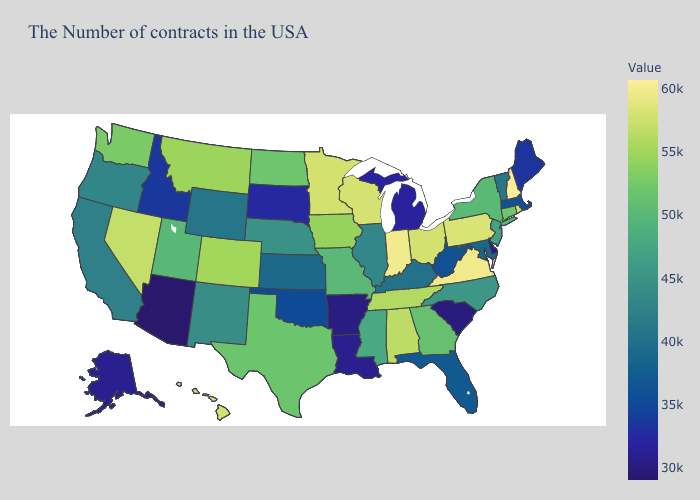Does the map have missing data?
Short answer required. No. Is the legend a continuous bar?
Be succinct. Yes. Which states have the lowest value in the USA?
Keep it brief. Arizona. Does Indiana have the highest value in the MidWest?
Answer briefly. Yes. 